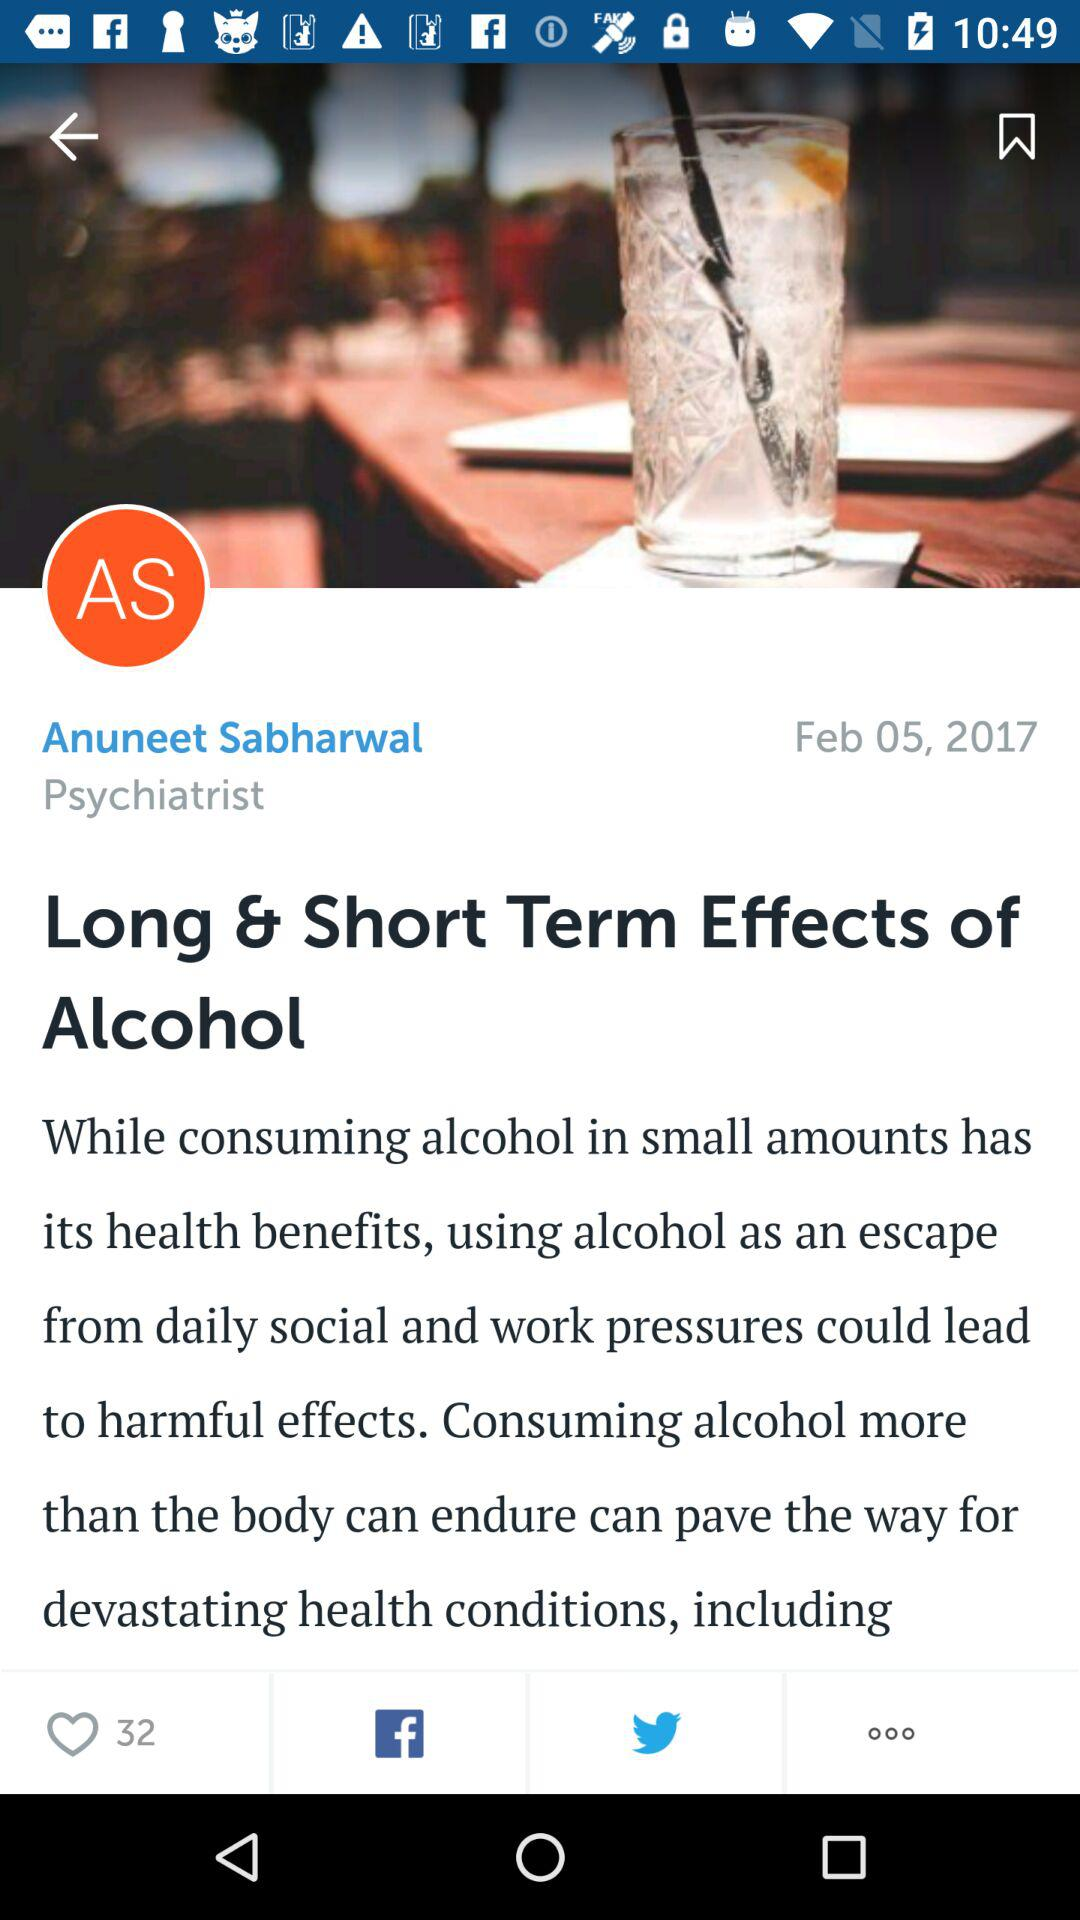What is the date? The date is February 05, 2017. 